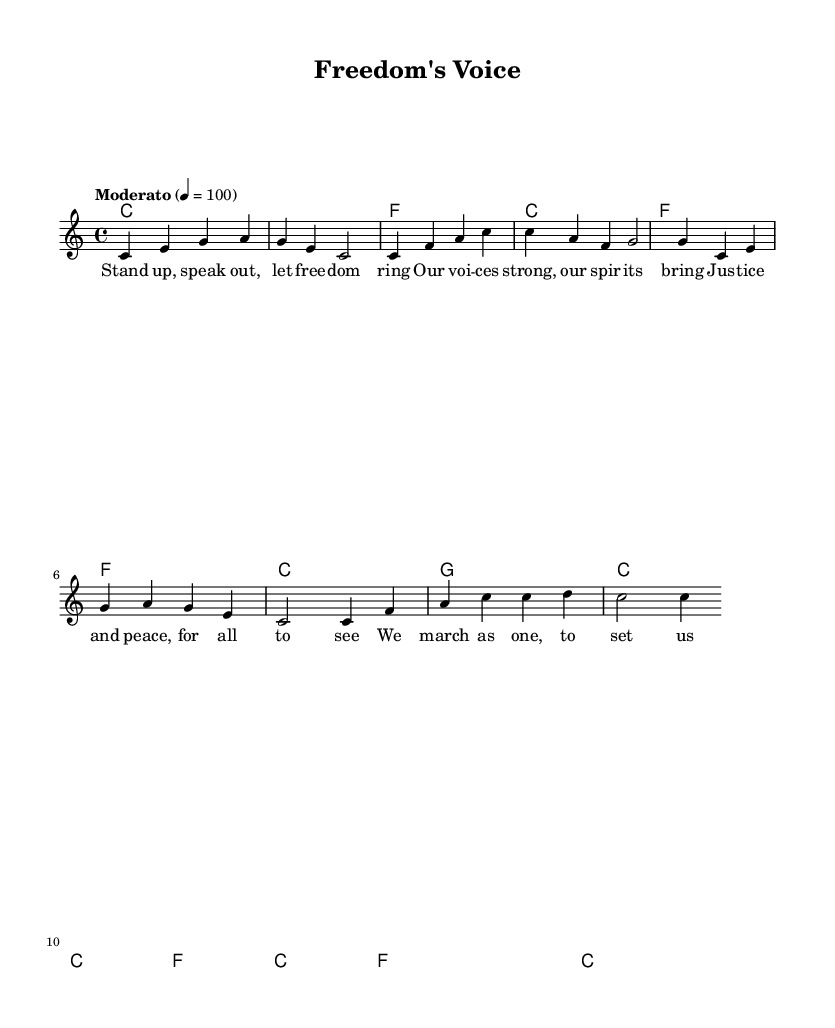What is the key signature of this music? The key signature is identified by looking at the beginning of the staff. In this case, there are no sharps or flats indicated, which means the key is C major.
Answer: C major What is the time signature of this piece? The time signature is found at the beginning of the music and is represented as a fraction. Here, it is shown as 4 over 4, meaning there are four beats per measure.
Answer: 4/4 What is the tempo marking for this piece? The tempo marking is present in the score, indicated above the staff. The marking "Moderato" suggests a moderate speed, and the number "4 = 100" specifies that the quarter note gets 100 beats per minute.
Answer: Moderato, 100 How many measures does the melody contain? To determine the number of measures in the melody, one counts each vertical barline in the music. There are a total of 8 measures in the provided melody section.
Answer: 8 What message does the text convey? The text of the song expresses themes of unity, justice, and freedom, emphasizing the importance of standing together for rights. The lyrics specifically call for justice and peace.
Answer: Justice and peace What is the first note of the melody? The first note of the melody line is found at the very start of the staff. It is a "c" note, which is the tonic of the key.
Answer: c How does the harmony support the melody? The harmony is built using chord structures that complement the melody notes. Each chord supports the corresponding melody by providing a resonant background, enriching the musical texture. For example, the presence of the C major chord directly supports the opening melody.
Answer: Chords complement melody 